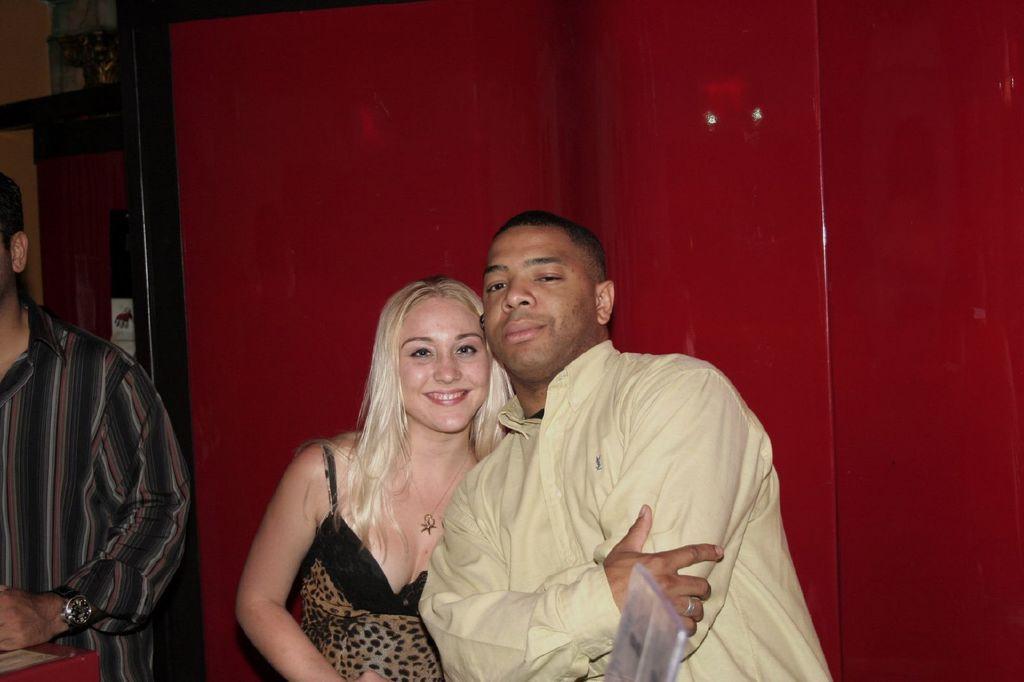In one or two sentences, can you explain what this image depicts? In this image I see 2 men and a woman and I see that this woman is smiling and I see that this man is wearing a shirt and this woman is wearing black and brown dress and in the background I see the red color thing over here and I see that this man is wearing a watch. 